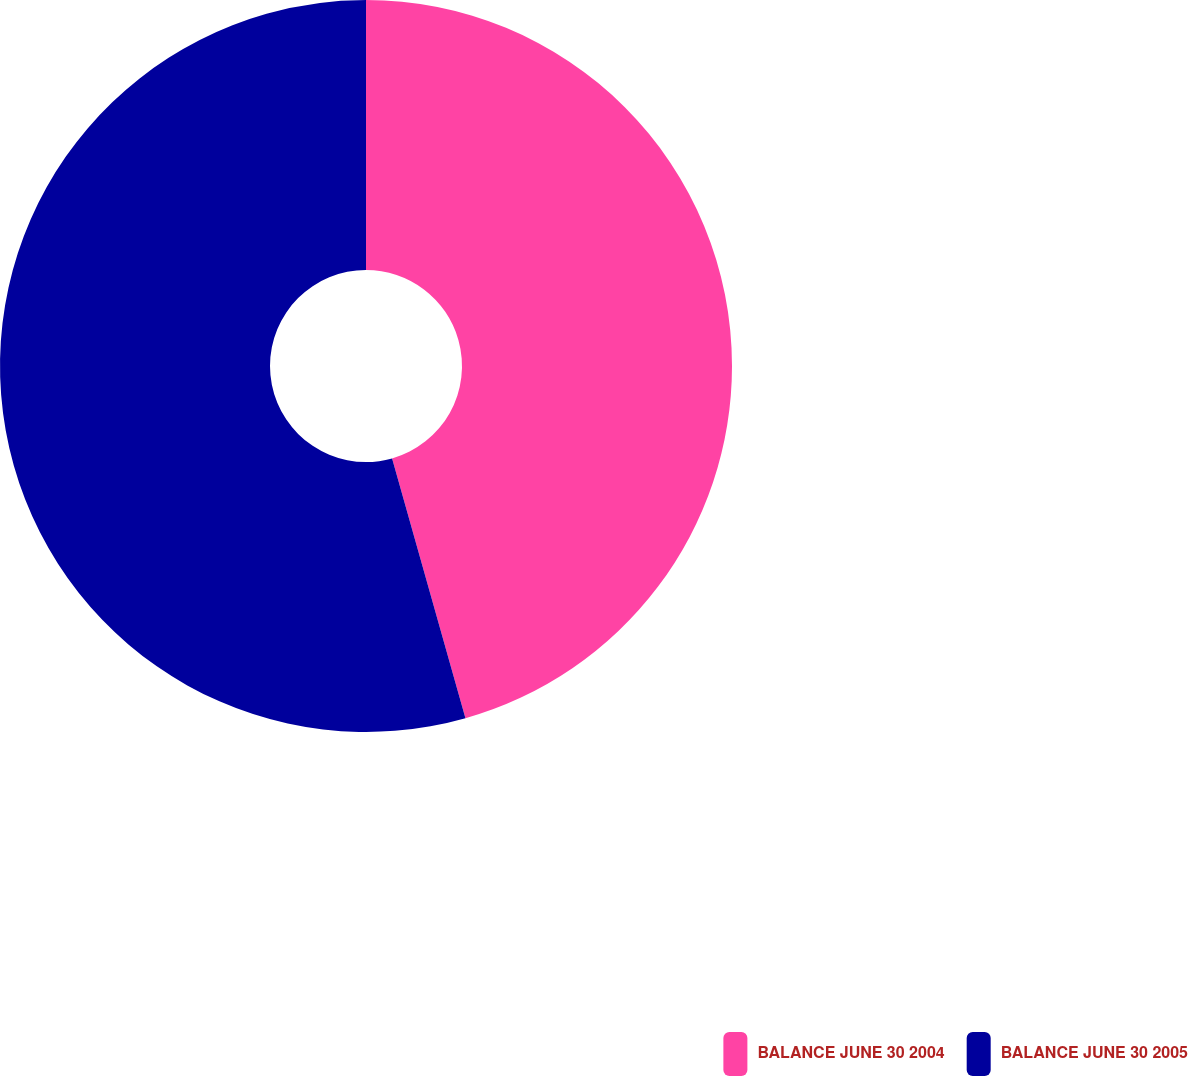Convert chart. <chart><loc_0><loc_0><loc_500><loc_500><pie_chart><fcel>BALANCE JUNE 30 2004<fcel>BALANCE JUNE 30 2005<nl><fcel>45.62%<fcel>54.38%<nl></chart> 